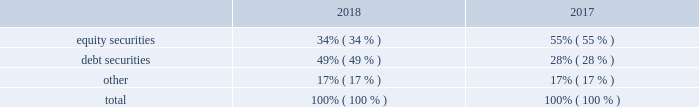Masco corporation notes to consolidated financial statements ( continued ) m .
Employee retirement plans ( continued ) plan assets .
Our qualified defined-benefit pension plan weighted average asset allocation , which is based upon fair value , was as follows: .
For our qualified defined-benefit pension plans , we have adopted accounting guidance that defines fair value , establishes a framework for measuring fair value and prescribes disclosures about fair value measurements .
Accounting guidance defines fair value as "the price that would be received to sell an asset or paid to transfer a liability in an orderly transaction between market participants at the measurement date." following is a description of the valuation methodologies used for assets measured at fair value .
There have been no changes in the methodologies used at december 31 , 2018 compared to december 31 , 2017 .
Common and preferred stocks and short-term and other investments : valued at the closing price reported on the active market on which the individual securities are traded or based on the active market for similar securities .
Certain investments are valued based on net asset value ( "nav" ) , which approximates fair value .
Such basis is determined by referencing the respective fund's underlying assets .
There are no unfunded commitments or other restrictions associated with these investments .
Private equity and hedge funds : valued based on an estimated fair value using either a market approach or an income approach , both of which require a significant degree of judgment .
There is no active trading market for these investments and they are generally illiquid .
Due to the significant unobservable inputs , the fair value measurements used to estimate fair value are a level 3 input .
Certain investments are valued based on nav , which approximates fair value .
Such basis is determined by referencing the respective fund's underlying assets .
There are no unfunded commitments or other restrictions associated with the investments valued at nav .
Corporate , government and other debt securities : valued based on either the closing price reported on the active market on which the individual securities are traded or using pricing models maximizing the use of observable inputs for similar securities .
This includes basing value on yields currently available on comparable securities of issuers with similar credit ratings .
Certain investments are valued based on nav , which approximates fair value .
Such basis is determined by referencing the respective fund's underlying assets .
There are unfunded commitments of $ 1 million and no other restrictions associated with these investments .
Common collective trust fund : valued based on an amortized cost basis , which approximates fair value .
Such basis is determined by reference to the respective fund's underlying assets , which are primarily cash equivalents .
There are no unfunded commitments or other restrictions associated with this fund .
Buy-in annuity : valued based on the associated benefit obligation for which the buy-in annuity covers the benefits , which approximates fair value .
Such basis is determined based on various assumptions , including the discount rate , long-term rate of return on plan assets and mortality rate .
The methods described above may produce a fair value calculation that may not be indicative of net realizable value or reflective of future fair values .
Furthermore , while we believe our valuation methods are appropriate and consistent with other market participants , the use of different methodologies or assumptions to determine the fair value of certain financial instruments could result in a different fair value measurement at the reporting date .
The following tables set forth , by level within the fair value hierarchy , the qualified defined-benefit pension plan assets at fair value as of december 31 , 2018 and 2017 , as well as those valued at nav using the practical expedient , which approximates fair value , in millions. .
In 2018 what was the debt to the equity ratio? 
Rationale: in 2018 the ratio of the debt to the equity was 1.44
Computations: (49 / 34)
Answer: 1.44118. 